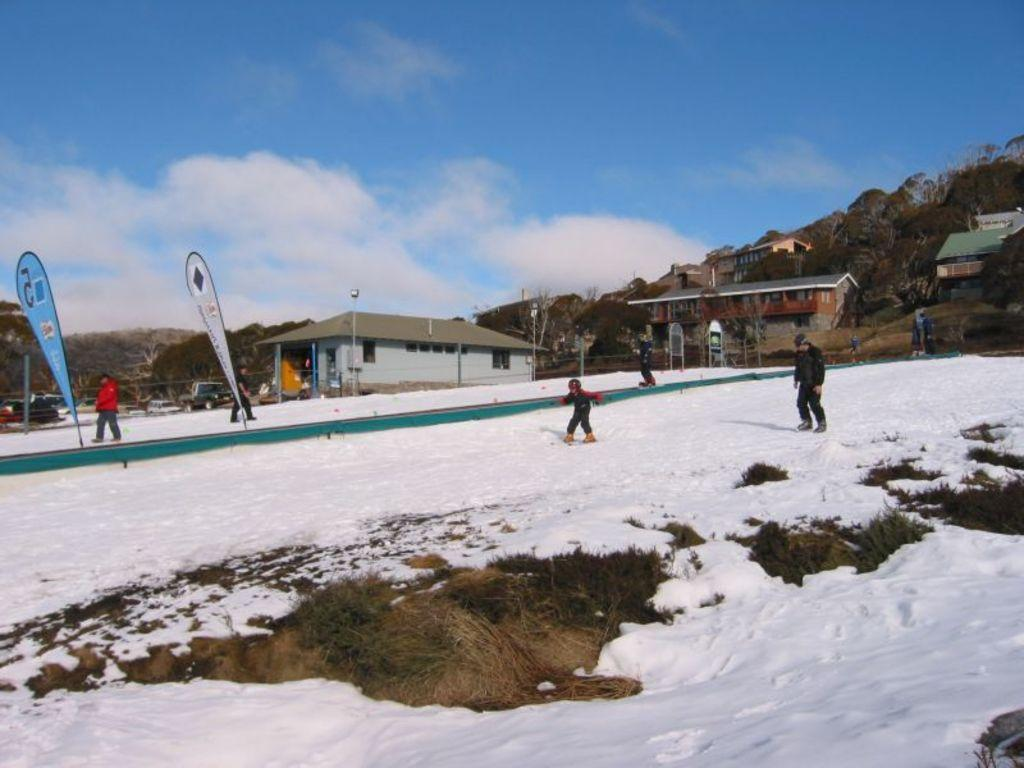How many people are in the image? There are persons in the image, but the exact number is not specified. What are the persons wearing? The persons are wearing clothes. What activity are the persons engaged in? The persons are skating on the snow. What can be seen in the sky? There are clouds in the sky. What type of brake system is used by the skaters in the image? There is no mention of a brake system in the image, as the persons are skating on snow. How many rings are visible on the fingers of the persons in the image? There is no information about rings or any jewelry worn by the persons in the image. 